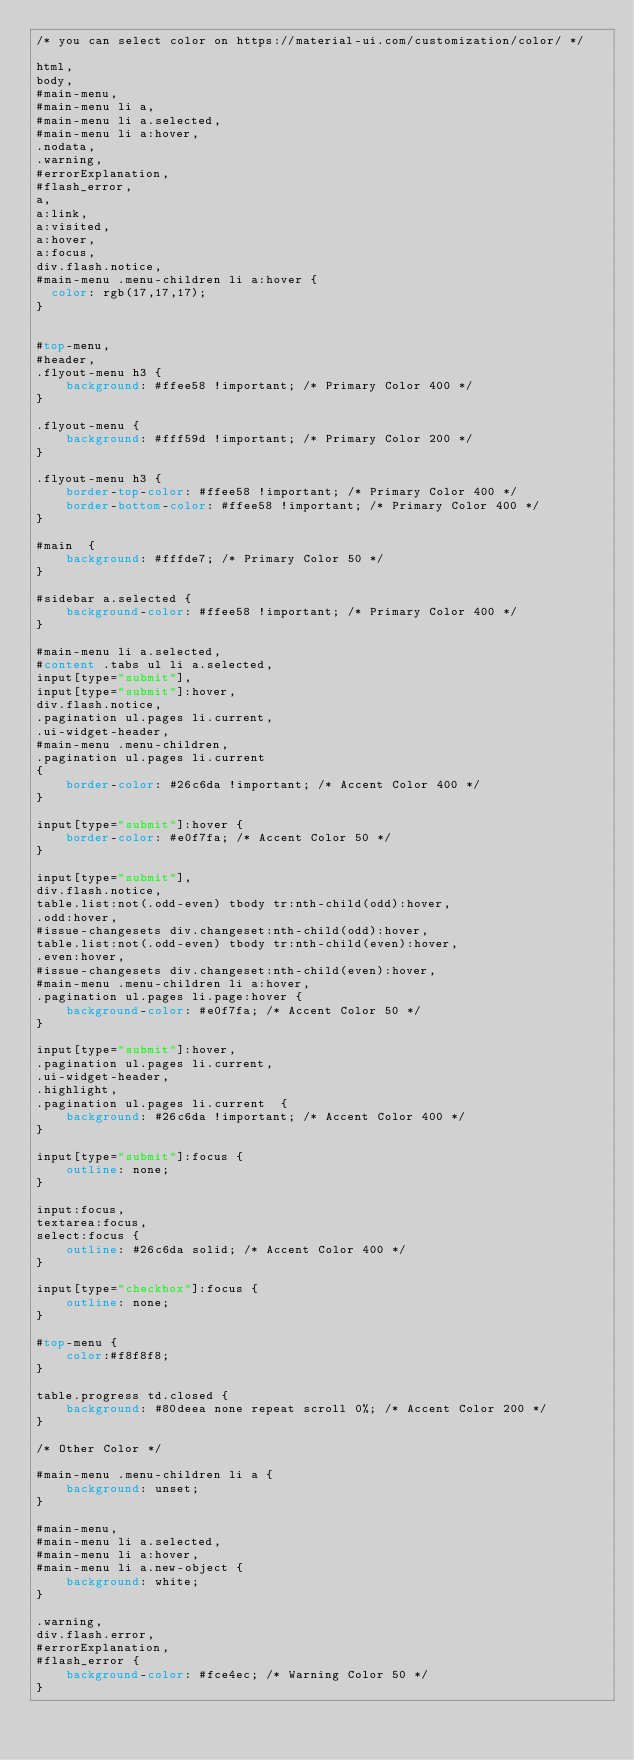Convert code to text. <code><loc_0><loc_0><loc_500><loc_500><_CSS_>/* you can select color on https://material-ui.com/customization/color/ */

html,
body,
#main-menu,
#main-menu li a,
#main-menu li a.selected,
#main-menu li a:hover,
.nodata,
.warning,
#errorExplanation,
#flash_error,
a, 
a:link, 
a:visited,
a:hover,
a:focus,
div.flash.notice,
#main-menu .menu-children li a:hover {
  color: rgb(17,17,17);
}


#top-menu,
#header,
.flyout-menu h3 {
    background: #ffee58 !important; /* Primary Color 400 */
}

.flyout-menu {
    background: #fff59d !important; /* Primary Color 200 */
}

.flyout-menu h3 {
    border-top-color: #ffee58 !important; /* Primary Color 400 */
    border-bottom-color: #ffee58 !important; /* Primary Color 400 */
}

#main  {
    background: #fffde7; /* Primary Color 50 */
}

#sidebar a.selected {
    background-color: #ffee58 !important; /* Primary Color 400 */
}

#main-menu li a.selected,
#content .tabs ul li a.selected,
input[type="submit"],
input[type="submit"]:hover,
div.flash.notice,
.pagination ul.pages li.current,
.ui-widget-header,
#main-menu .menu-children,
.pagination ul.pages li.current
{
    border-color: #26c6da !important; /* Accent Color 400 */
}

input[type="submit"]:hover {
    border-color: #e0f7fa; /* Accent Color 50 */
}

input[type="submit"], 
div.flash.notice,
table.list:not(.odd-even) tbody tr:nth-child(odd):hover,
.odd:hover,
#issue-changesets div.changeset:nth-child(odd):hover,
table.list:not(.odd-even) tbody tr:nth-child(even):hover,
.even:hover,
#issue-changesets div.changeset:nth-child(even):hover,
#main-menu .menu-children li a:hover,
.pagination ul.pages li.page:hover {
    background-color: #e0f7fa; /* Accent Color 50 */
}

input[type="submit"]:hover,
.pagination ul.pages li.current,
.ui-widget-header,
.highlight,
.pagination ul.pages li.current  {
    background: #26c6da !important; /* Accent Color 400 */
}

input[type="submit"]:focus {
    outline: none;
}

input:focus,
textarea:focus,
select:focus {
    outline: #26c6da solid; /* Accent Color 400 */
}

input[type="checkbox"]:focus {
    outline: none;
}

#top-menu {
    color:#f8f8f8;
}

table.progress td.closed {
    background: #80deea none repeat scroll 0%; /* Accent Color 200 */
}

/* Other Color */

#main-menu .menu-children li a {
    background: unset;
}

#main-menu,
#main-menu li a.selected,
#main-menu li a:hover,
#main-menu li a.new-object {
    background: white;
}

.warning,
div.flash.error,
#errorExplanation,
#flash_error {
    background-color: #fce4ec; /* Warning Color 50 */
}
</code> 